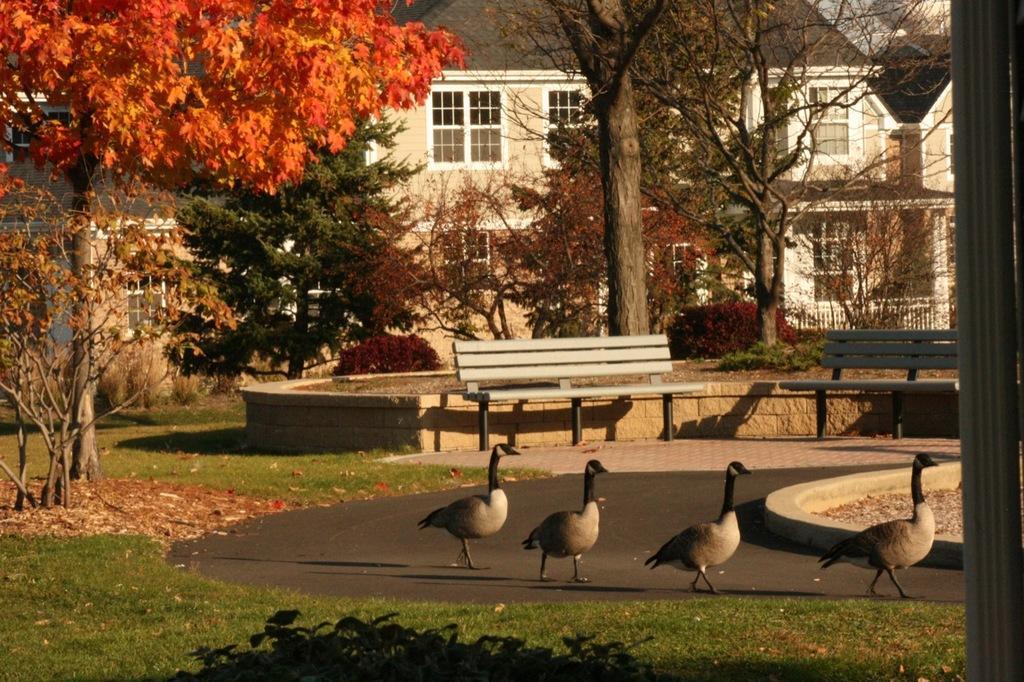Could you give a brief overview of what you see in this image? The picture is clicked on a road where there are four ducks walking on the road. In the background there are tables , trees and there is a orange color leaf tree. There are also buildings in the background with glass windows. 